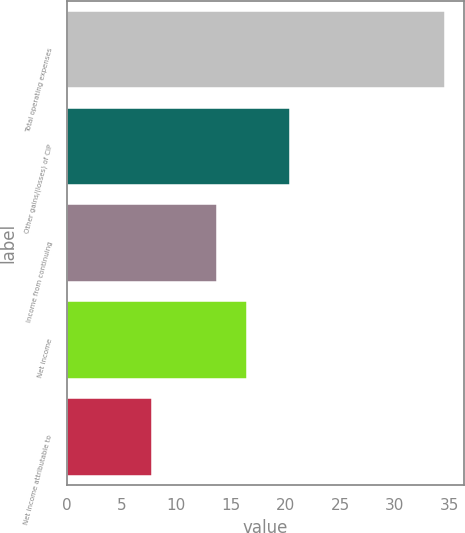<chart> <loc_0><loc_0><loc_500><loc_500><bar_chart><fcel>Total operating expenses<fcel>Other gains/(losses) of CIP<fcel>Income from continuing<fcel>Net income<fcel>Net income attributable to<nl><fcel>34.6<fcel>20.4<fcel>13.78<fcel>16.46<fcel>7.8<nl></chart> 